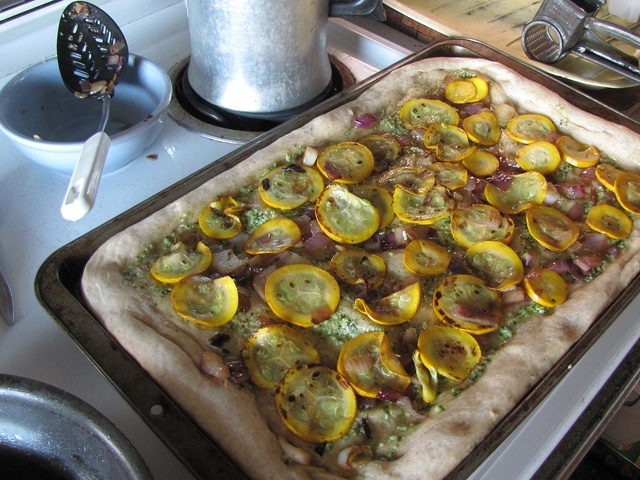Describe the objects in this image and their specific colors. I can see oven in gray, black, olive, darkgray, and tan tones, pizza in teal, olive, tan, and maroon tones, bowl in teal, black, darkblue, and gray tones, spoon in teal, black, lightgray, gray, and darkgray tones, and orange in teal, tan, orange, and olive tones in this image. 